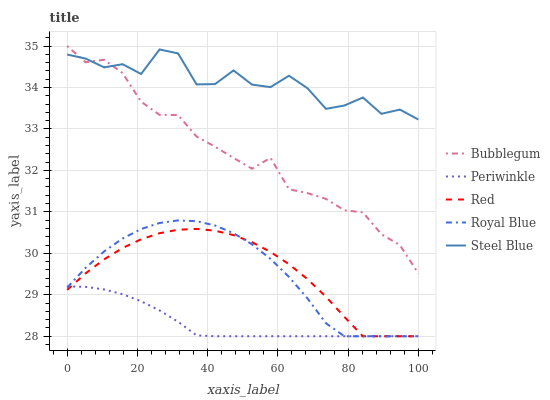Does Periwinkle have the minimum area under the curve?
Answer yes or no. Yes. Does Steel Blue have the maximum area under the curve?
Answer yes or no. Yes. Does Red have the minimum area under the curve?
Answer yes or no. No. Does Red have the maximum area under the curve?
Answer yes or no. No. Is Periwinkle the smoothest?
Answer yes or no. Yes. Is Steel Blue the roughest?
Answer yes or no. Yes. Is Red the smoothest?
Answer yes or no. No. Is Red the roughest?
Answer yes or no. No. Does Royal Blue have the lowest value?
Answer yes or no. Yes. Does Bubblegum have the lowest value?
Answer yes or no. No. Does Bubblegum have the highest value?
Answer yes or no. Yes. Does Red have the highest value?
Answer yes or no. No. Is Royal Blue less than Steel Blue?
Answer yes or no. Yes. Is Bubblegum greater than Red?
Answer yes or no. Yes. Does Periwinkle intersect Royal Blue?
Answer yes or no. Yes. Is Periwinkle less than Royal Blue?
Answer yes or no. No. Is Periwinkle greater than Royal Blue?
Answer yes or no. No. Does Royal Blue intersect Steel Blue?
Answer yes or no. No. 